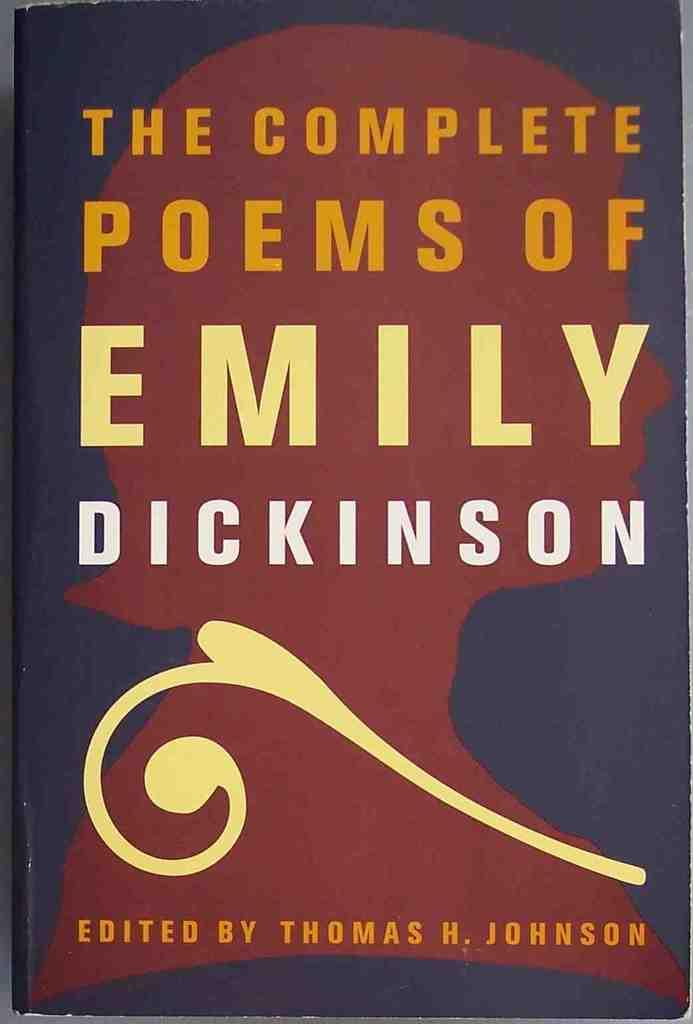<image>
Create a compact narrative representing the image presented. The cover of a book shows it has poems by Emily Dickenson 